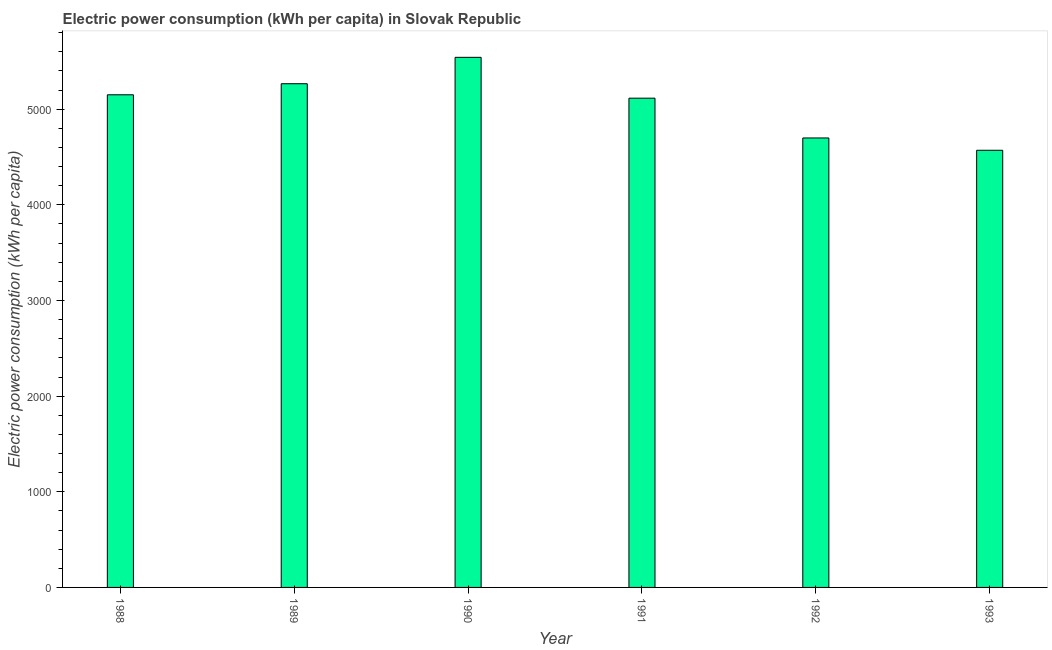What is the title of the graph?
Keep it short and to the point. Electric power consumption (kWh per capita) in Slovak Republic. What is the label or title of the Y-axis?
Ensure brevity in your answer.  Electric power consumption (kWh per capita). What is the electric power consumption in 1993?
Offer a very short reply. 4570.44. Across all years, what is the maximum electric power consumption?
Your answer should be very brief. 5542.17. Across all years, what is the minimum electric power consumption?
Offer a terse response. 4570.44. In which year was the electric power consumption maximum?
Your response must be concise. 1990. In which year was the electric power consumption minimum?
Make the answer very short. 1993. What is the sum of the electric power consumption?
Provide a short and direct response. 3.03e+04. What is the difference between the electric power consumption in 1988 and 1990?
Provide a short and direct response. -391.71. What is the average electric power consumption per year?
Provide a succinct answer. 5057.25. What is the median electric power consumption?
Ensure brevity in your answer.  5132.79. Do a majority of the years between 1993 and 1989 (inclusive) have electric power consumption greater than 4600 kWh per capita?
Make the answer very short. Yes. What is the ratio of the electric power consumption in 1990 to that in 1993?
Offer a terse response. 1.21. Is the electric power consumption in 1988 less than that in 1989?
Your response must be concise. Yes. What is the difference between the highest and the second highest electric power consumption?
Your response must be concise. 276. What is the difference between the highest and the lowest electric power consumption?
Provide a short and direct response. 971.73. In how many years, is the electric power consumption greater than the average electric power consumption taken over all years?
Make the answer very short. 4. How many bars are there?
Give a very brief answer. 6. Are all the bars in the graph horizontal?
Ensure brevity in your answer.  No. How many years are there in the graph?
Offer a very short reply. 6. What is the difference between two consecutive major ticks on the Y-axis?
Offer a terse response. 1000. What is the Electric power consumption (kWh per capita) in 1988?
Your answer should be compact. 5150.46. What is the Electric power consumption (kWh per capita) of 1989?
Your response must be concise. 5266.17. What is the Electric power consumption (kWh per capita) in 1990?
Your response must be concise. 5542.17. What is the Electric power consumption (kWh per capita) of 1991?
Offer a very short reply. 5115.12. What is the Electric power consumption (kWh per capita) in 1992?
Provide a succinct answer. 4699.14. What is the Electric power consumption (kWh per capita) in 1993?
Your answer should be very brief. 4570.44. What is the difference between the Electric power consumption (kWh per capita) in 1988 and 1989?
Ensure brevity in your answer.  -115.71. What is the difference between the Electric power consumption (kWh per capita) in 1988 and 1990?
Your response must be concise. -391.71. What is the difference between the Electric power consumption (kWh per capita) in 1988 and 1991?
Offer a very short reply. 35.34. What is the difference between the Electric power consumption (kWh per capita) in 1988 and 1992?
Offer a terse response. 451.33. What is the difference between the Electric power consumption (kWh per capita) in 1988 and 1993?
Your answer should be very brief. 580.02. What is the difference between the Electric power consumption (kWh per capita) in 1989 and 1990?
Your response must be concise. -276. What is the difference between the Electric power consumption (kWh per capita) in 1989 and 1991?
Ensure brevity in your answer.  151.05. What is the difference between the Electric power consumption (kWh per capita) in 1989 and 1992?
Provide a short and direct response. 567.03. What is the difference between the Electric power consumption (kWh per capita) in 1989 and 1993?
Give a very brief answer. 695.73. What is the difference between the Electric power consumption (kWh per capita) in 1990 and 1991?
Your answer should be very brief. 427.05. What is the difference between the Electric power consumption (kWh per capita) in 1990 and 1992?
Make the answer very short. 843.03. What is the difference between the Electric power consumption (kWh per capita) in 1990 and 1993?
Provide a short and direct response. 971.73. What is the difference between the Electric power consumption (kWh per capita) in 1991 and 1992?
Provide a short and direct response. 415.99. What is the difference between the Electric power consumption (kWh per capita) in 1991 and 1993?
Your answer should be compact. 544.68. What is the difference between the Electric power consumption (kWh per capita) in 1992 and 1993?
Keep it short and to the point. 128.7. What is the ratio of the Electric power consumption (kWh per capita) in 1988 to that in 1989?
Offer a very short reply. 0.98. What is the ratio of the Electric power consumption (kWh per capita) in 1988 to that in 1990?
Your answer should be compact. 0.93. What is the ratio of the Electric power consumption (kWh per capita) in 1988 to that in 1991?
Your answer should be very brief. 1.01. What is the ratio of the Electric power consumption (kWh per capita) in 1988 to that in 1992?
Offer a very short reply. 1.1. What is the ratio of the Electric power consumption (kWh per capita) in 1988 to that in 1993?
Keep it short and to the point. 1.13. What is the ratio of the Electric power consumption (kWh per capita) in 1989 to that in 1990?
Offer a very short reply. 0.95. What is the ratio of the Electric power consumption (kWh per capita) in 1989 to that in 1991?
Your response must be concise. 1.03. What is the ratio of the Electric power consumption (kWh per capita) in 1989 to that in 1992?
Ensure brevity in your answer.  1.12. What is the ratio of the Electric power consumption (kWh per capita) in 1989 to that in 1993?
Offer a terse response. 1.15. What is the ratio of the Electric power consumption (kWh per capita) in 1990 to that in 1991?
Your response must be concise. 1.08. What is the ratio of the Electric power consumption (kWh per capita) in 1990 to that in 1992?
Ensure brevity in your answer.  1.18. What is the ratio of the Electric power consumption (kWh per capita) in 1990 to that in 1993?
Give a very brief answer. 1.21. What is the ratio of the Electric power consumption (kWh per capita) in 1991 to that in 1992?
Provide a succinct answer. 1.09. What is the ratio of the Electric power consumption (kWh per capita) in 1991 to that in 1993?
Your answer should be compact. 1.12. What is the ratio of the Electric power consumption (kWh per capita) in 1992 to that in 1993?
Provide a succinct answer. 1.03. 